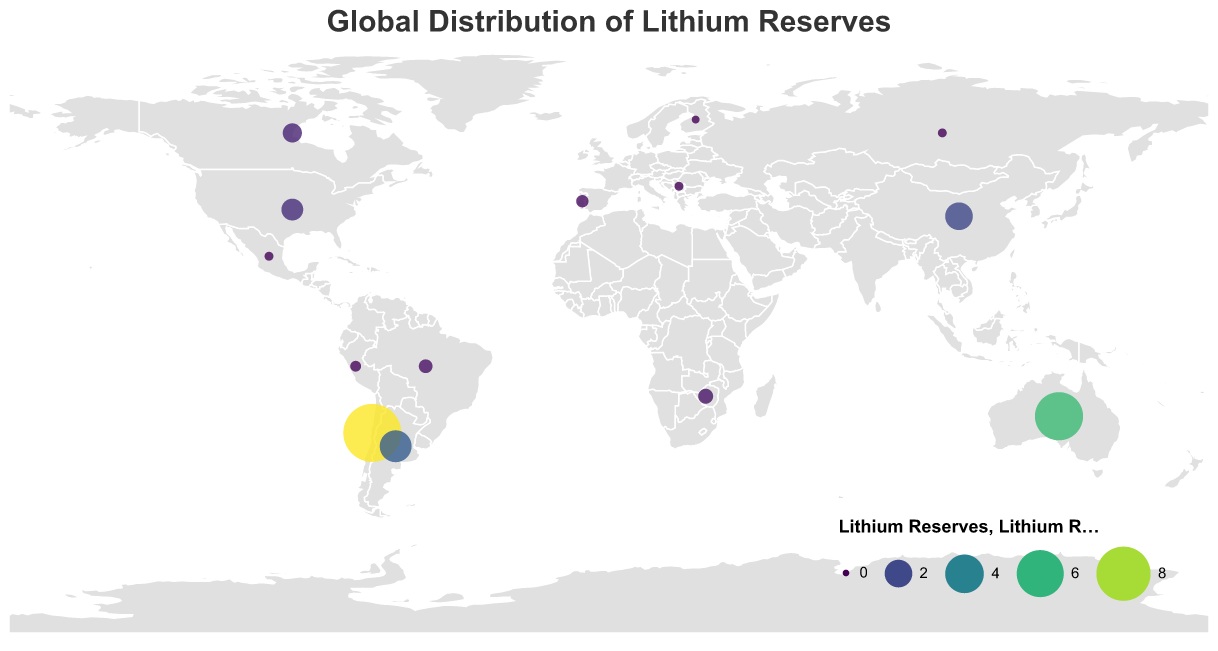What's the title of the geographic plot? The title is usually located at the top of the figure and describes the main subject of the plot. Here, the title is "Global Distribution of Lithium Reserves," which summarizes the figure's focus on the worldwide spread of lithium reserves across different countries.
Answer: Global Distribution of Lithium Reserves Which country has the largest lithium reserves? To find the country with the largest lithium reserves, look for the data point or visual element with the highest value in the legend or tooltip. Chile is shown as having the largest circle, indicating the highest amount of lithium reserves.
Answer: Chile What is the total sum of lithium reserves in Argentina and China? Identify the individual values for Argentina and China from the plot (Argentina: 2.7 million tonnes, China: 2.0 million tonnes) and then add them together (2.7 + 2.0).
Answer: 4.7 million tonnes Compare the lithium reserves of Australia and the United States. Which country has more? Refer to the plot and check the values for Australia and the United States. Australia has 6.3 million tonnes, whereas the United States has 1.2 million tonnes. Hence, Australia has more.
Answer: Australia Which countries have less than 1 million tonnes of lithium reserves? Look at the countries with small circle sizes and refer to the legend or tooltip data to identify them. These countries are Canada, Zimbabwe, Brazil, Portugal, Peru, Mexico, Russia, Serbia, and Finland.
Answer: Canada, Zimbabwe, Brazil, Portugal, Peru, Mexico, Russia, Serbia, Finland What is the difference in lithium reserves between Chile and Portugal? First, get the values of lithium reserves for Chile (9.2 million tonnes) and Portugal (0.3 million tonnes). Subtract the reserves of Portugal from Chile's reserves (9.2 - 0.3).
Answer: 8.9 million tonnes Which continent has the highest lithium reserves represented in the plot? Identify the countries and their respective continents, then sum up the lithium reserves for each continent. South America (Chile and Argentina) sums up to 11.9 million tonnes, which appears to be the highest.
Answer: South America What color represents countries with the highest lithium reserves on the plot? Check the color scale legend in the plot, where the color associated with the highest values will be most intense. The dark colors, especially those like dark purple or blue, typically indicate higher values.
Answer: Dark purple/blue Considering only the top three countries, what percentage of the total lithium reserves do they hold? Add the lithium reserves of Chile, Australia, and Argentina (9.2 + 6.3 + 2.7 = 18.2 million tonnes). Then, sum the total reserves of all listed countries, which is 25.15 million tonnes. Calculate the percentage (18.2 / 25.15 * 100).
Answer: Approximately 72.4% What is the relative position of Zimbabwe's lithium reserves compared to Canada and Brazil? From the plot, find the values for Zimbabwe, Canada, and Brazil. Zimbabwe has 0.5 million tonnes, Canada has 0.9 million tonnes, and Brazil has 0.4 million tonnes. Zimbabwe's reserves are more than Brazil's but less than Canada's.
Answer: Between Canada and Brazil 